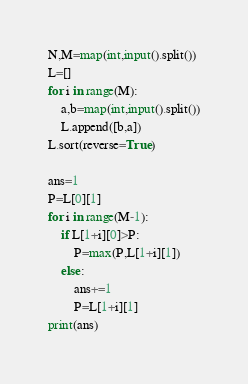Convert code to text. <code><loc_0><loc_0><loc_500><loc_500><_Python_>N,M=map(int,input().split())
L=[]
for i in range(M):
    a,b=map(int,input().split())
    L.append([b,a])
L.sort(reverse=True)
    
ans=1
P=L[0][1]
for i in range(M-1):
    if L[1+i][0]>P:
        P=max(P,L[1+i][1])
    else:
        ans+=1
        P=L[1+i][1]
print(ans)</code> 